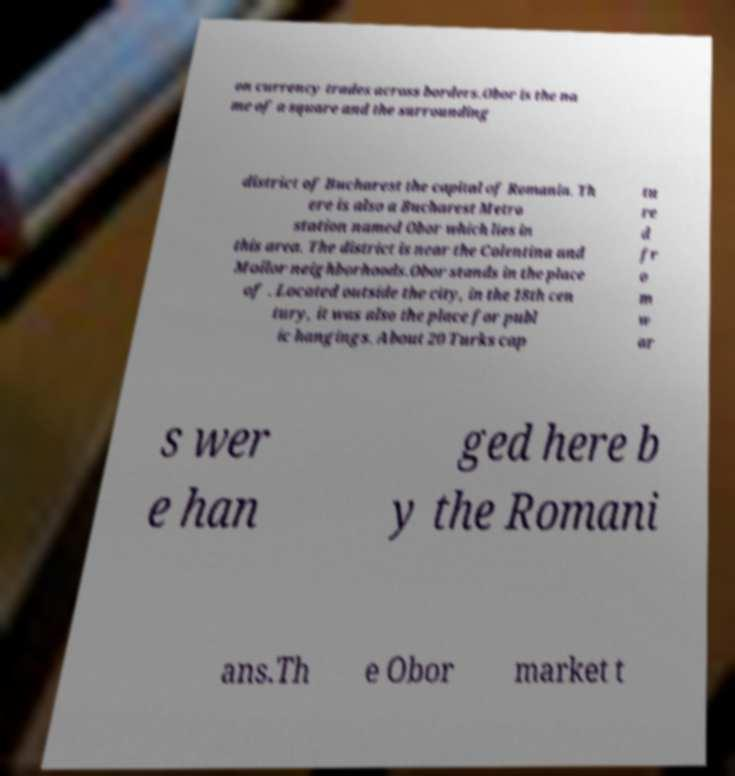For documentation purposes, I need the text within this image transcribed. Could you provide that? on currency trades across borders.Obor is the na me of a square and the surrounding district of Bucharest the capital of Romania. Th ere is also a Bucharest Metro station named Obor which lies in this area. The district is near the Colentina and Moilor neighborhoods.Obor stands in the place of . Located outside the city, in the 18th cen tury, it was also the place for publ ic hangings. About 20 Turks cap tu re d fr o m w ar s wer e han ged here b y the Romani ans.Th e Obor market t 